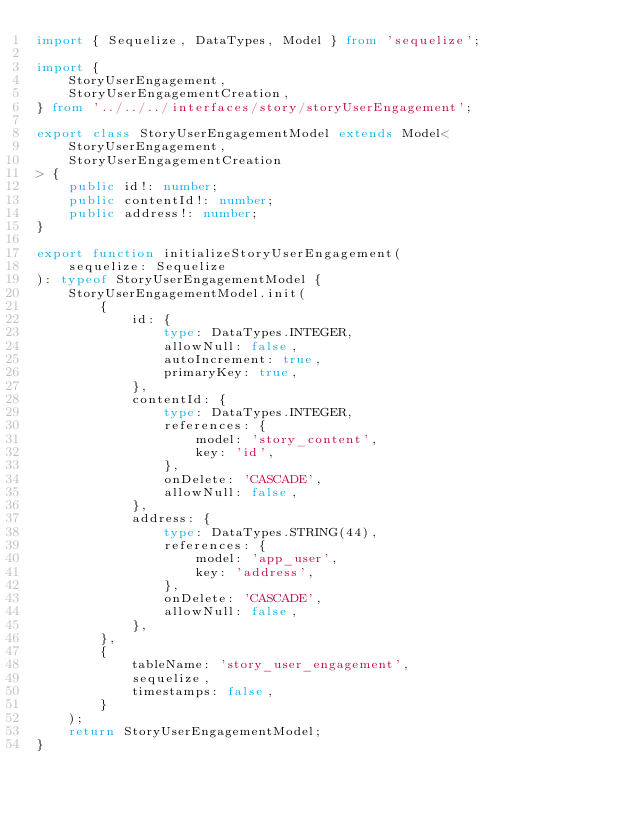<code> <loc_0><loc_0><loc_500><loc_500><_TypeScript_>import { Sequelize, DataTypes, Model } from 'sequelize';

import {
    StoryUserEngagement,
    StoryUserEngagementCreation,
} from '../../../interfaces/story/storyUserEngagement';

export class StoryUserEngagementModel extends Model<
    StoryUserEngagement,
    StoryUserEngagementCreation
> {
    public id!: number;
    public contentId!: number;
    public address!: number;
}

export function initializeStoryUserEngagement(
    sequelize: Sequelize
): typeof StoryUserEngagementModel {
    StoryUserEngagementModel.init(
        {
            id: {
                type: DataTypes.INTEGER,
                allowNull: false,
                autoIncrement: true,
                primaryKey: true,
            },
            contentId: {
                type: DataTypes.INTEGER,
                references: {
                    model: 'story_content',
                    key: 'id',
                },
                onDelete: 'CASCADE',
                allowNull: false,
            },
            address: {
                type: DataTypes.STRING(44),
                references: {
                    model: 'app_user',
                    key: 'address',
                },
                onDelete: 'CASCADE',
                allowNull: false,
            },
        },
        {
            tableName: 'story_user_engagement',
            sequelize,
            timestamps: false,
        }
    );
    return StoryUserEngagementModel;
}
</code> 